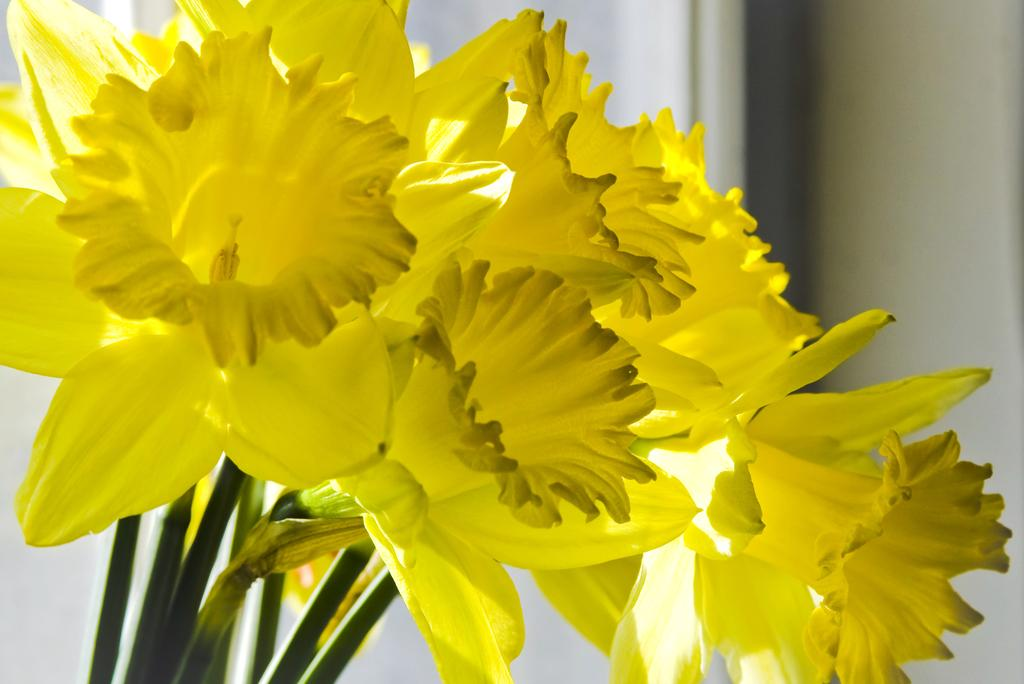What type of living organisms can be seen in the image? There is a group of flowers on stems in the image. What can be seen in the background of the image? There is a wall visible in the background of the image. What type of chicken is being prepared with a knife in the image? There is no chicken or knife present in the image; it features a group of flowers on stems and a wall in the background. 